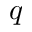Convert formula to latex. <formula><loc_0><loc_0><loc_500><loc_500>q</formula> 